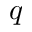Convert formula to latex. <formula><loc_0><loc_0><loc_500><loc_500>q</formula> 